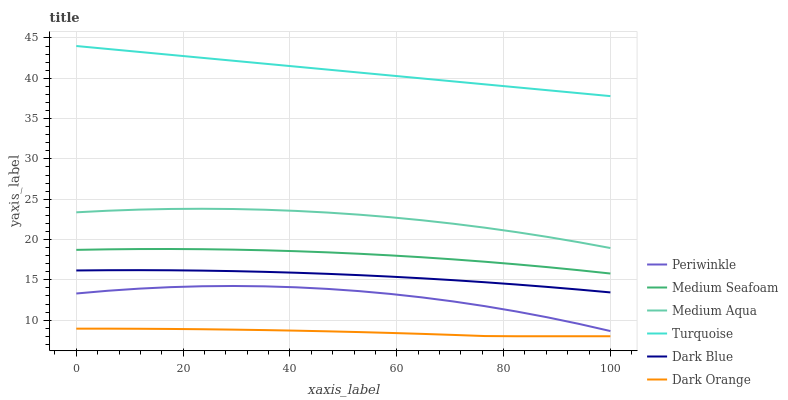Does Dark Orange have the minimum area under the curve?
Answer yes or no. Yes. Does Turquoise have the maximum area under the curve?
Answer yes or no. Yes. Does Dark Blue have the minimum area under the curve?
Answer yes or no. No. Does Dark Blue have the maximum area under the curve?
Answer yes or no. No. Is Turquoise the smoothest?
Answer yes or no. Yes. Is Periwinkle the roughest?
Answer yes or no. Yes. Is Dark Blue the smoothest?
Answer yes or no. No. Is Dark Blue the roughest?
Answer yes or no. No. Does Dark Orange have the lowest value?
Answer yes or no. Yes. Does Dark Blue have the lowest value?
Answer yes or no. No. Does Turquoise have the highest value?
Answer yes or no. Yes. Does Dark Blue have the highest value?
Answer yes or no. No. Is Dark Orange less than Dark Blue?
Answer yes or no. Yes. Is Medium Seafoam greater than Periwinkle?
Answer yes or no. Yes. Does Dark Orange intersect Dark Blue?
Answer yes or no. No. 